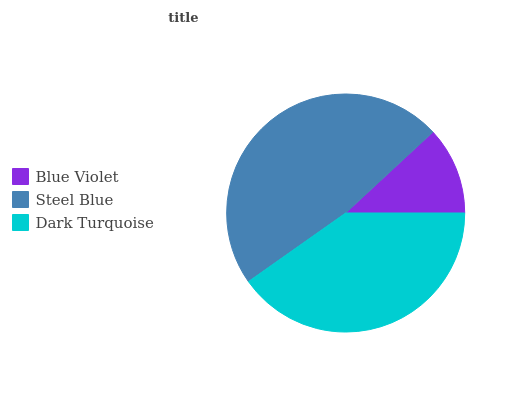Is Blue Violet the minimum?
Answer yes or no. Yes. Is Steel Blue the maximum?
Answer yes or no. Yes. Is Dark Turquoise the minimum?
Answer yes or no. No. Is Dark Turquoise the maximum?
Answer yes or no. No. Is Steel Blue greater than Dark Turquoise?
Answer yes or no. Yes. Is Dark Turquoise less than Steel Blue?
Answer yes or no. Yes. Is Dark Turquoise greater than Steel Blue?
Answer yes or no. No. Is Steel Blue less than Dark Turquoise?
Answer yes or no. No. Is Dark Turquoise the high median?
Answer yes or no. Yes. Is Dark Turquoise the low median?
Answer yes or no. Yes. Is Blue Violet the high median?
Answer yes or no. No. Is Steel Blue the low median?
Answer yes or no. No. 